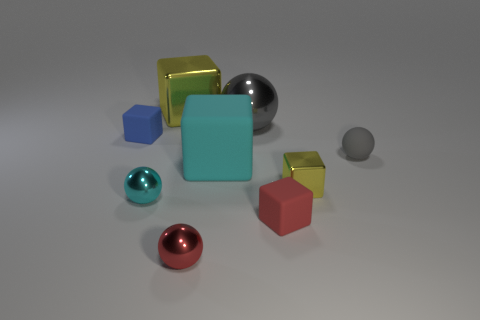How many cyan objects are cylinders or tiny shiny objects?
Offer a terse response. 1. There is a large object that is in front of the tiny blue thing; does it have the same color as the big metallic cube?
Give a very brief answer. No. There is a gray object that is made of the same material as the tiny yellow thing; what is its shape?
Your response must be concise. Sphere. What color is the tiny matte thing that is to the right of the tiny cyan ball and behind the tiny cyan metal ball?
Provide a succinct answer. Gray. There is a yellow shiny object that is behind the gray sphere in front of the tiny blue rubber block; what size is it?
Ensure brevity in your answer.  Large. Is there another rubber ball that has the same color as the large ball?
Offer a very short reply. Yes. Is the number of small yellow blocks that are on the right side of the tiny rubber sphere the same as the number of small green cylinders?
Make the answer very short. Yes. How many cyan rubber things are there?
Provide a succinct answer. 1. The object that is both on the left side of the big yellow object and in front of the gray rubber ball has what shape?
Offer a terse response. Sphere. Do the object to the right of the small yellow metallic cube and the shiny sphere that is behind the cyan metal thing have the same color?
Give a very brief answer. Yes. 